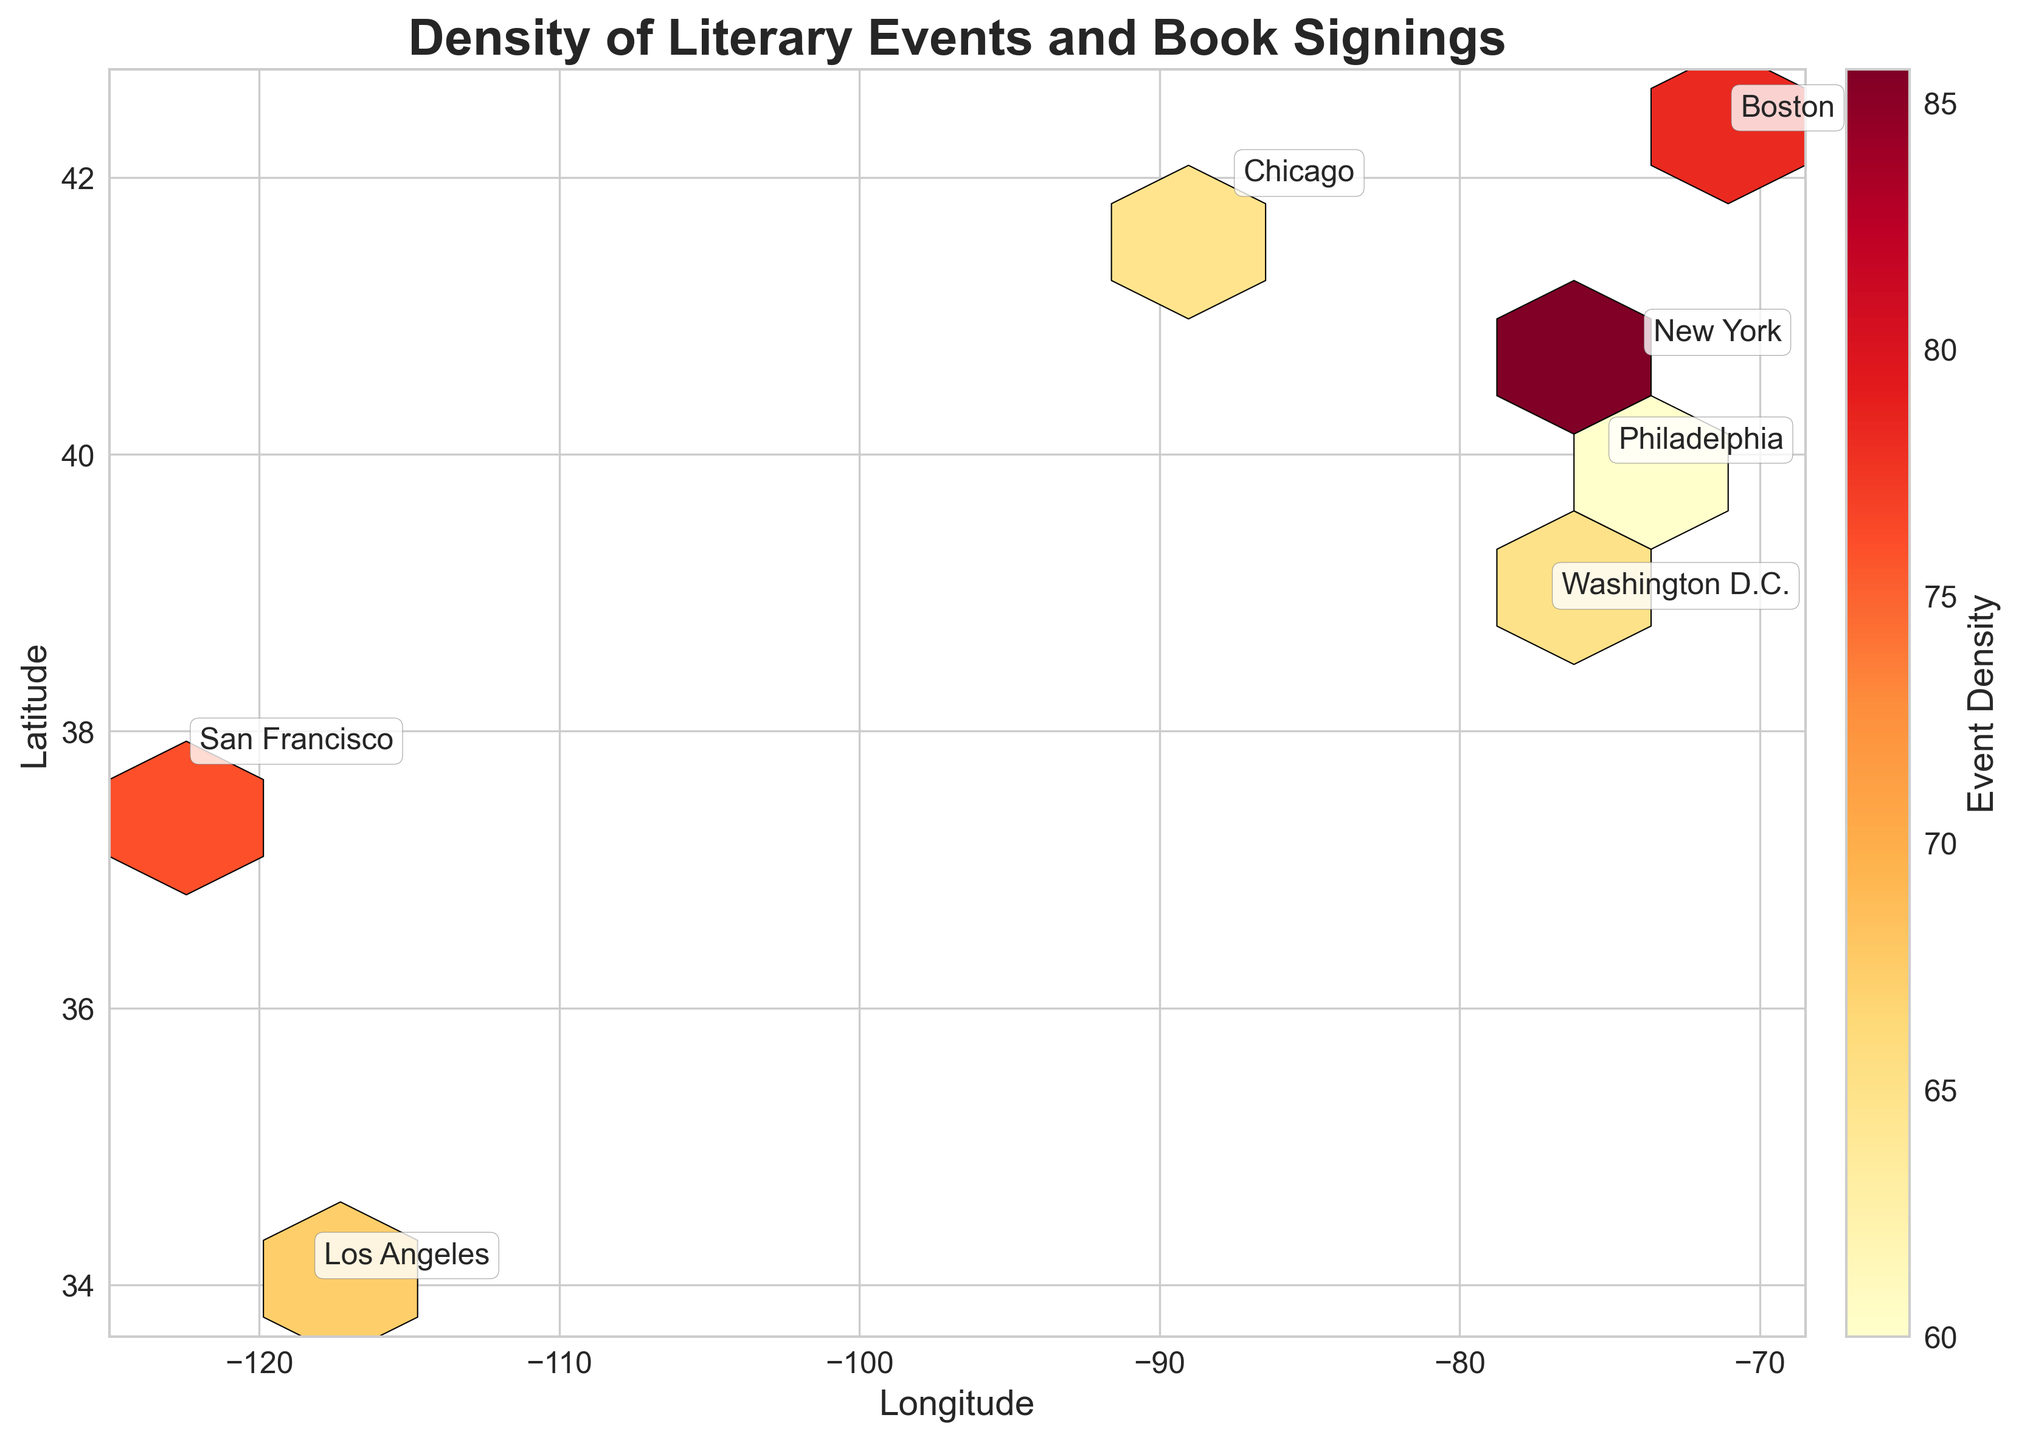What is the title of the plot? The title is typically located at the top of the plot. It provides a succinct description of what the plot represents, ensuring the reader understands the context of the data presented.
Answer: "Density of Literary Events and Book Signings" Which city appears to have the highest density of events? Look for the area with the darkest hexagons on the plot, as darker hexagons represent higher event densities. This typically corresponds to New York based on the provided data.
Answer: New York What does the colorbar represent? The colorbar on the side of the plot generally provides a reference for interpreting the colors within the plot. It indicates what different colors mean regarding event density.
Answer: Event Density Are there any annotations for the cities? The plot contains text annotations at certain points, typically centered around average coordinates of cities to label them.
Answer: Yes Which city has the lowest event density near the central point? Identify the lightest-colored hexagons in the hexbin plot, which indicate the lowest density, around the center. Based on known data points, Washington D.C. might have lower densities in some central areas compared to other cities.
Answer: Washington D.C What range of density values is shown on the colorbar? Examine the color bar, which typically indicates the range of density values from minimum to maximum. This provides context for the interpretation of the plot's color variations.
Answer: The range is from the lowest to highest density value based on the event data Which area (latitude and longitude) shows the densest concentration of literary events? Locate the hexagon with the darkest color as it represents the highest density. The `x` and `y` coordinates of this hexagon likely correspond to somewhere in or around New York City.
Answer: Around (-73.98, 40.75) Which city has a higher average density of literary events, Boston or Los Angeles? Compare the average color intensity of the hexagons around the annotated locations for Boston and Los Angeles. Boston has generally darker hexagons which suggests a higher density.
Answer: Boston Which city has a book signing density closest to 70 events? Check the hexagons' colors and their respective density values as shown in the colorbar, and then match them with annotated city locations. San Francisco and Washington D.C. have densities closest to 70.
Answer: San Francisco, Washington D.C How are the cities distinguished in the plot? Observe how each city is visually separated through annotations and possibly clusters of hexagons around certain coordinates. This approach helps differentiate the cities.
Answer: Annotations and clustering of hexagons 